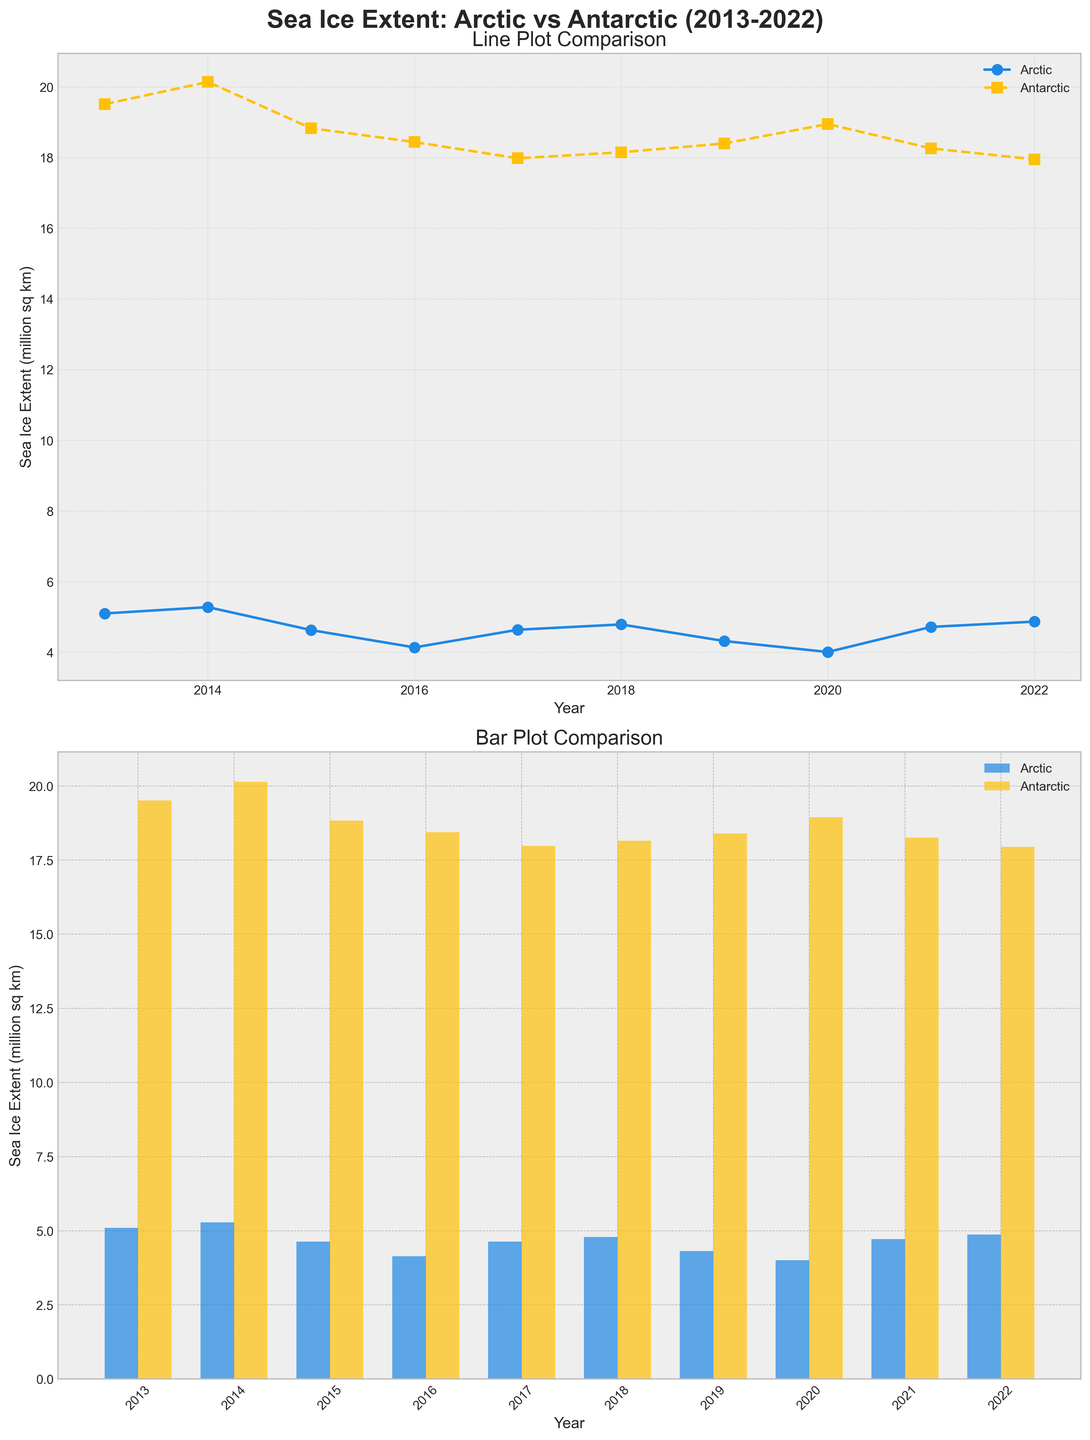What is the title of the figure? The title is usually at the top of the figure and provides a brief description of what the figure is about. By looking at the top part of the figure, you can see the title "Sea Ice Extent: Arctic vs Antarctic (2013-2022)".
Answer: Sea Ice Extent: Arctic vs Antarctic (2013-2022) How many years of data are displayed in the figure? Each year is represented as a distinct data point along the x-axis. By counting these points, you can determine the number of years covered. In this figure, there are 10 data points corresponding to the years 2013 to 2022.
Answer: 10 years Which year had the lowest sea ice extent in the Arctic according to the line plot? In the line plot, look for the point on the Arctic line (blue) that is the lowest vertically. The lowest point on the Arctic line appears over the year 2020.
Answer: 2020 Compare the sea ice extent in the Arctic for the years 2017 and 2021; which year had a larger extent? By finding the points for 2017 and 2021 on the Arctic line (blue), you can compare the vertical positions. The point for 2021 is higher than the point for 2017 on the line plot, indicating that 2021 had a larger extent.
Answer: 2021 What is the color used to represent the Antarctic sea ice extent in the line plot? The different series in the line plot use distinct colors. The legend indicates that the Antarctic sea ice extent is represented with the color yellow.
Answer: Yellow In which year did the Antarctic sea ice extent reach its highest value according to the bar plot? By examining the heights of the bars for the Antarctic series, the tallest bar corresponds to the maximum value. The tallest bar for the Antarctic sea ice extent is in 2014.
Answer: 2014 What's the difference in sea ice extent between the Arctic and Antarctic in 2016 according to the line plot? Locate the points for 2016 on both the Arctic (blue) and Antarctic (yellow) lines. The values are 4.14 for the Arctic and 18.44 for the Antarctic. The difference is 18.44 - 4.14 = 14.30 million sq km.
Answer: 14.30 million sq km What is the trend in the Arctic sea ice extent from 2013 to 2022 as depicted in the line plot? Observe the general direction of the Arctic line (blue) over the years. The line shows a decreasing trend from 2013 to 2022, indicating a decline in sea ice extent over the decade.
Answer: Decreasing Which year had the closest sea ice extent values between the Arctic and Antarctic? Compare the vertical heights of both the Arctic (blue) and Antarctic (yellow) lines for each year to find the minimum difference. In 2019, the difference is the smallest: Arctic (4.32) and Antarctic (18.40), difference = 18.40 - 4.32 = 14.08 million sq km. This is the smallest difference observed.
Answer: 2019 How does the bar plot arrangement help in understanding the annual comparison of sea ice extent between the Arctic and Antarctic? The bar plot uses side-by-side bars for each year, making it easy to compare the height (value) of the Arctic and Antarctic bars for each year directly. This visual arrangement highlights the differences and similarities in sea ice extent year by year.
Answer: Side-by-side comparison 